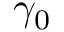Convert formula to latex. <formula><loc_0><loc_0><loc_500><loc_500>\gamma _ { 0 }</formula> 